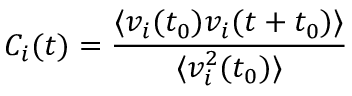<formula> <loc_0><loc_0><loc_500><loc_500>{ C _ { i } ( t ) = \frac { \langle v _ { i } ( t _ { 0 } ) v _ { i } ( t + t _ { 0 } ) \rangle } { \langle v _ { i } ^ { 2 } ( t _ { 0 } ) \rangle } }</formula> 